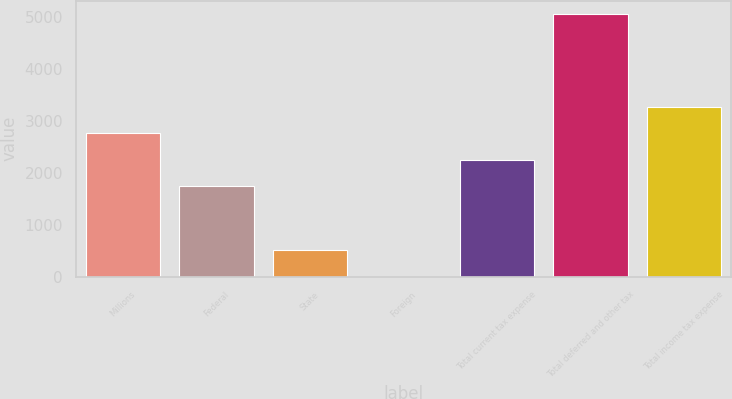Convert chart to OTSL. <chart><loc_0><loc_0><loc_500><loc_500><bar_chart><fcel>Millions<fcel>Federal<fcel>State<fcel>Foreign<fcel>Total current tax expense<fcel>Total deferred and other tax<fcel>Total income tax expense<nl><fcel>2763<fcel>1750<fcel>508.5<fcel>2<fcel>2256.5<fcel>5067<fcel>3269.5<nl></chart> 